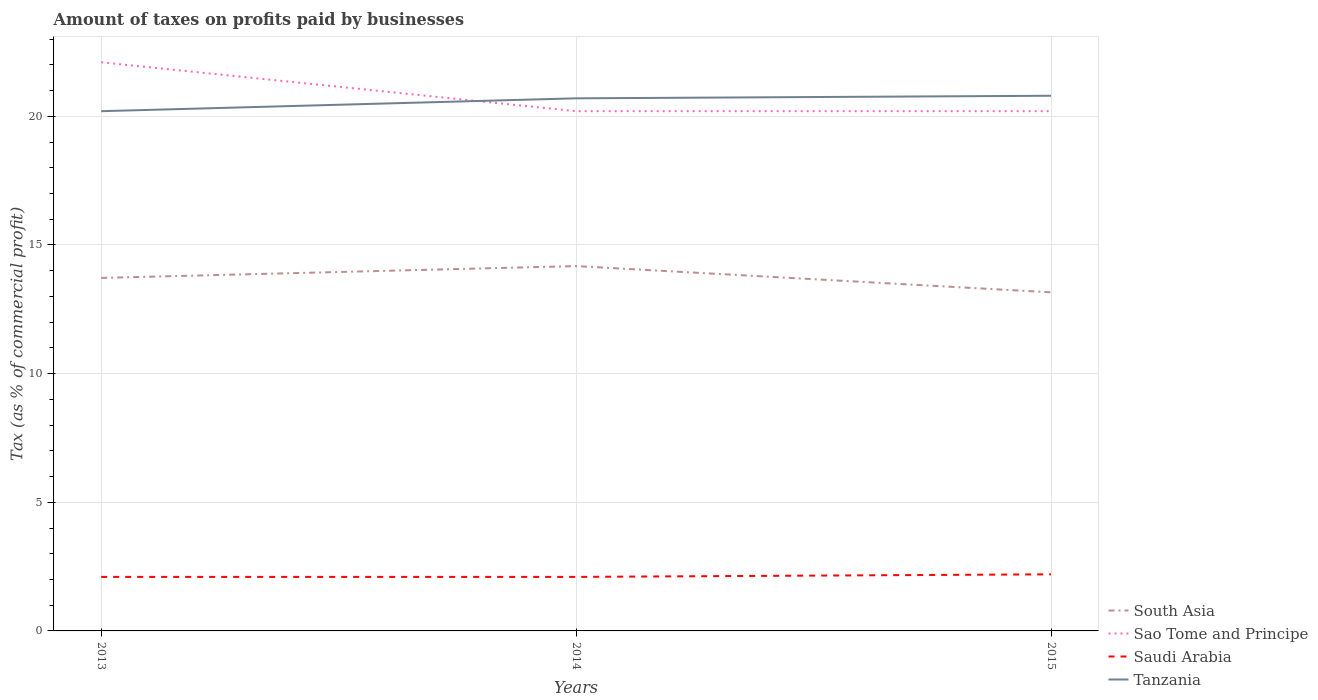Does the line corresponding to Saudi Arabia intersect with the line corresponding to Tanzania?
Your answer should be compact. No. In which year was the percentage of taxes paid by businesses in South Asia maximum?
Your answer should be compact. 2015. What is the total percentage of taxes paid by businesses in Sao Tome and Principe in the graph?
Provide a short and direct response. 1.9. What is the difference between the highest and the second highest percentage of taxes paid by businesses in Saudi Arabia?
Make the answer very short. 0.1. Is the percentage of taxes paid by businesses in Sao Tome and Principe strictly greater than the percentage of taxes paid by businesses in South Asia over the years?
Provide a succinct answer. No. How many years are there in the graph?
Offer a terse response. 3. Does the graph contain any zero values?
Provide a succinct answer. No. How are the legend labels stacked?
Offer a very short reply. Vertical. What is the title of the graph?
Your answer should be very brief. Amount of taxes on profits paid by businesses. Does "Tonga" appear as one of the legend labels in the graph?
Offer a very short reply. No. What is the label or title of the Y-axis?
Keep it short and to the point. Tax (as % of commercial profit). What is the Tax (as % of commercial profit) in South Asia in 2013?
Keep it short and to the point. 13.72. What is the Tax (as % of commercial profit) of Sao Tome and Principe in 2013?
Provide a short and direct response. 22.1. What is the Tax (as % of commercial profit) of Tanzania in 2013?
Your answer should be very brief. 20.2. What is the Tax (as % of commercial profit) in South Asia in 2014?
Provide a short and direct response. 14.18. What is the Tax (as % of commercial profit) in Sao Tome and Principe in 2014?
Offer a terse response. 20.2. What is the Tax (as % of commercial profit) of Saudi Arabia in 2014?
Ensure brevity in your answer.  2.1. What is the Tax (as % of commercial profit) in Tanzania in 2014?
Ensure brevity in your answer.  20.7. What is the Tax (as % of commercial profit) of South Asia in 2015?
Ensure brevity in your answer.  13.16. What is the Tax (as % of commercial profit) of Sao Tome and Principe in 2015?
Ensure brevity in your answer.  20.2. What is the Tax (as % of commercial profit) in Tanzania in 2015?
Offer a very short reply. 20.8. Across all years, what is the maximum Tax (as % of commercial profit) of South Asia?
Offer a terse response. 14.18. Across all years, what is the maximum Tax (as % of commercial profit) in Sao Tome and Principe?
Give a very brief answer. 22.1. Across all years, what is the maximum Tax (as % of commercial profit) in Saudi Arabia?
Ensure brevity in your answer.  2.2. Across all years, what is the maximum Tax (as % of commercial profit) of Tanzania?
Your answer should be very brief. 20.8. Across all years, what is the minimum Tax (as % of commercial profit) of South Asia?
Give a very brief answer. 13.16. Across all years, what is the minimum Tax (as % of commercial profit) in Sao Tome and Principe?
Offer a very short reply. 20.2. Across all years, what is the minimum Tax (as % of commercial profit) of Saudi Arabia?
Give a very brief answer. 2.1. Across all years, what is the minimum Tax (as % of commercial profit) of Tanzania?
Keep it short and to the point. 20.2. What is the total Tax (as % of commercial profit) of South Asia in the graph?
Give a very brief answer. 41.06. What is the total Tax (as % of commercial profit) in Sao Tome and Principe in the graph?
Give a very brief answer. 62.5. What is the total Tax (as % of commercial profit) in Saudi Arabia in the graph?
Provide a short and direct response. 6.4. What is the total Tax (as % of commercial profit) in Tanzania in the graph?
Keep it short and to the point. 61.7. What is the difference between the Tax (as % of commercial profit) of South Asia in 2013 and that in 2014?
Your response must be concise. -0.46. What is the difference between the Tax (as % of commercial profit) of Sao Tome and Principe in 2013 and that in 2014?
Make the answer very short. 1.9. What is the difference between the Tax (as % of commercial profit) of Tanzania in 2013 and that in 2014?
Give a very brief answer. -0.5. What is the difference between the Tax (as % of commercial profit) of South Asia in 2013 and that in 2015?
Keep it short and to the point. 0.56. What is the difference between the Tax (as % of commercial profit) of Sao Tome and Principe in 2013 and that in 2015?
Your answer should be compact. 1.9. What is the difference between the Tax (as % of commercial profit) of Tanzania in 2013 and that in 2015?
Give a very brief answer. -0.6. What is the difference between the Tax (as % of commercial profit) of South Asia in 2014 and that in 2015?
Offer a very short reply. 1.02. What is the difference between the Tax (as % of commercial profit) in Tanzania in 2014 and that in 2015?
Your response must be concise. -0.1. What is the difference between the Tax (as % of commercial profit) in South Asia in 2013 and the Tax (as % of commercial profit) in Sao Tome and Principe in 2014?
Make the answer very short. -6.48. What is the difference between the Tax (as % of commercial profit) of South Asia in 2013 and the Tax (as % of commercial profit) of Saudi Arabia in 2014?
Give a very brief answer. 11.62. What is the difference between the Tax (as % of commercial profit) in South Asia in 2013 and the Tax (as % of commercial profit) in Tanzania in 2014?
Offer a terse response. -6.98. What is the difference between the Tax (as % of commercial profit) of Sao Tome and Principe in 2013 and the Tax (as % of commercial profit) of Tanzania in 2014?
Your answer should be compact. 1.4. What is the difference between the Tax (as % of commercial profit) in Saudi Arabia in 2013 and the Tax (as % of commercial profit) in Tanzania in 2014?
Keep it short and to the point. -18.6. What is the difference between the Tax (as % of commercial profit) in South Asia in 2013 and the Tax (as % of commercial profit) in Sao Tome and Principe in 2015?
Ensure brevity in your answer.  -6.48. What is the difference between the Tax (as % of commercial profit) in South Asia in 2013 and the Tax (as % of commercial profit) in Saudi Arabia in 2015?
Keep it short and to the point. 11.52. What is the difference between the Tax (as % of commercial profit) of South Asia in 2013 and the Tax (as % of commercial profit) of Tanzania in 2015?
Provide a succinct answer. -7.08. What is the difference between the Tax (as % of commercial profit) of Sao Tome and Principe in 2013 and the Tax (as % of commercial profit) of Saudi Arabia in 2015?
Your answer should be compact. 19.9. What is the difference between the Tax (as % of commercial profit) of Sao Tome and Principe in 2013 and the Tax (as % of commercial profit) of Tanzania in 2015?
Your answer should be very brief. 1.3. What is the difference between the Tax (as % of commercial profit) of Saudi Arabia in 2013 and the Tax (as % of commercial profit) of Tanzania in 2015?
Your answer should be very brief. -18.7. What is the difference between the Tax (as % of commercial profit) in South Asia in 2014 and the Tax (as % of commercial profit) in Sao Tome and Principe in 2015?
Keep it short and to the point. -6.02. What is the difference between the Tax (as % of commercial profit) in South Asia in 2014 and the Tax (as % of commercial profit) in Saudi Arabia in 2015?
Ensure brevity in your answer.  11.98. What is the difference between the Tax (as % of commercial profit) of South Asia in 2014 and the Tax (as % of commercial profit) of Tanzania in 2015?
Your answer should be very brief. -6.62. What is the difference between the Tax (as % of commercial profit) of Sao Tome and Principe in 2014 and the Tax (as % of commercial profit) of Saudi Arabia in 2015?
Your response must be concise. 18. What is the difference between the Tax (as % of commercial profit) in Saudi Arabia in 2014 and the Tax (as % of commercial profit) in Tanzania in 2015?
Provide a succinct answer. -18.7. What is the average Tax (as % of commercial profit) in South Asia per year?
Provide a succinct answer. 13.69. What is the average Tax (as % of commercial profit) in Sao Tome and Principe per year?
Your response must be concise. 20.83. What is the average Tax (as % of commercial profit) in Saudi Arabia per year?
Provide a succinct answer. 2.13. What is the average Tax (as % of commercial profit) in Tanzania per year?
Your answer should be very brief. 20.57. In the year 2013, what is the difference between the Tax (as % of commercial profit) in South Asia and Tax (as % of commercial profit) in Sao Tome and Principe?
Give a very brief answer. -8.38. In the year 2013, what is the difference between the Tax (as % of commercial profit) of South Asia and Tax (as % of commercial profit) of Saudi Arabia?
Your answer should be very brief. 11.62. In the year 2013, what is the difference between the Tax (as % of commercial profit) in South Asia and Tax (as % of commercial profit) in Tanzania?
Ensure brevity in your answer.  -6.48. In the year 2013, what is the difference between the Tax (as % of commercial profit) of Sao Tome and Principe and Tax (as % of commercial profit) of Tanzania?
Give a very brief answer. 1.9. In the year 2013, what is the difference between the Tax (as % of commercial profit) of Saudi Arabia and Tax (as % of commercial profit) of Tanzania?
Your response must be concise. -18.1. In the year 2014, what is the difference between the Tax (as % of commercial profit) of South Asia and Tax (as % of commercial profit) of Sao Tome and Principe?
Your answer should be compact. -6.02. In the year 2014, what is the difference between the Tax (as % of commercial profit) in South Asia and Tax (as % of commercial profit) in Saudi Arabia?
Provide a short and direct response. 12.08. In the year 2014, what is the difference between the Tax (as % of commercial profit) of South Asia and Tax (as % of commercial profit) of Tanzania?
Provide a succinct answer. -6.52. In the year 2014, what is the difference between the Tax (as % of commercial profit) of Sao Tome and Principe and Tax (as % of commercial profit) of Tanzania?
Your response must be concise. -0.5. In the year 2014, what is the difference between the Tax (as % of commercial profit) in Saudi Arabia and Tax (as % of commercial profit) in Tanzania?
Your answer should be very brief. -18.6. In the year 2015, what is the difference between the Tax (as % of commercial profit) in South Asia and Tax (as % of commercial profit) in Sao Tome and Principe?
Make the answer very short. -7.04. In the year 2015, what is the difference between the Tax (as % of commercial profit) in South Asia and Tax (as % of commercial profit) in Saudi Arabia?
Keep it short and to the point. 10.96. In the year 2015, what is the difference between the Tax (as % of commercial profit) of South Asia and Tax (as % of commercial profit) of Tanzania?
Keep it short and to the point. -7.64. In the year 2015, what is the difference between the Tax (as % of commercial profit) of Saudi Arabia and Tax (as % of commercial profit) of Tanzania?
Offer a terse response. -18.6. What is the ratio of the Tax (as % of commercial profit) in South Asia in 2013 to that in 2014?
Offer a terse response. 0.97. What is the ratio of the Tax (as % of commercial profit) of Sao Tome and Principe in 2013 to that in 2014?
Keep it short and to the point. 1.09. What is the ratio of the Tax (as % of commercial profit) in Saudi Arabia in 2013 to that in 2014?
Make the answer very short. 1. What is the ratio of the Tax (as % of commercial profit) of Tanzania in 2013 to that in 2014?
Your answer should be compact. 0.98. What is the ratio of the Tax (as % of commercial profit) in South Asia in 2013 to that in 2015?
Keep it short and to the point. 1.04. What is the ratio of the Tax (as % of commercial profit) of Sao Tome and Principe in 2013 to that in 2015?
Make the answer very short. 1.09. What is the ratio of the Tax (as % of commercial profit) in Saudi Arabia in 2013 to that in 2015?
Give a very brief answer. 0.95. What is the ratio of the Tax (as % of commercial profit) of Tanzania in 2013 to that in 2015?
Your answer should be compact. 0.97. What is the ratio of the Tax (as % of commercial profit) in South Asia in 2014 to that in 2015?
Your response must be concise. 1.08. What is the ratio of the Tax (as % of commercial profit) in Saudi Arabia in 2014 to that in 2015?
Your response must be concise. 0.95. What is the ratio of the Tax (as % of commercial profit) of Tanzania in 2014 to that in 2015?
Your answer should be compact. 1. What is the difference between the highest and the second highest Tax (as % of commercial profit) in South Asia?
Keep it short and to the point. 0.46. What is the difference between the highest and the second highest Tax (as % of commercial profit) in Sao Tome and Principe?
Keep it short and to the point. 1.9. What is the difference between the highest and the second highest Tax (as % of commercial profit) in Tanzania?
Provide a succinct answer. 0.1. What is the difference between the highest and the lowest Tax (as % of commercial profit) in South Asia?
Give a very brief answer. 1.02. What is the difference between the highest and the lowest Tax (as % of commercial profit) in Sao Tome and Principe?
Ensure brevity in your answer.  1.9. What is the difference between the highest and the lowest Tax (as % of commercial profit) of Saudi Arabia?
Make the answer very short. 0.1. 